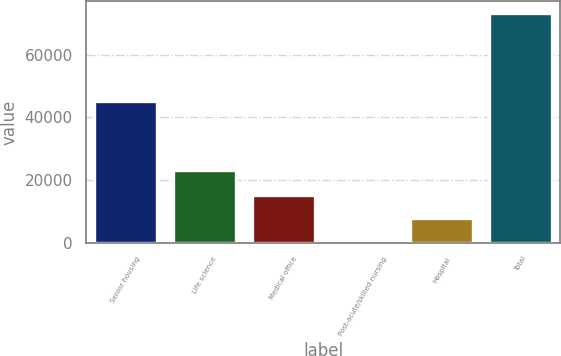<chart> <loc_0><loc_0><loc_500><loc_500><bar_chart><fcel>Senior housing<fcel>Life science<fcel>Medical office<fcel>Post-acute/skilled nursing<fcel>Hospital<fcel>Total<nl><fcel>45345<fcel>23026<fcel>15198.2<fcel>657<fcel>7927.6<fcel>73363<nl></chart> 